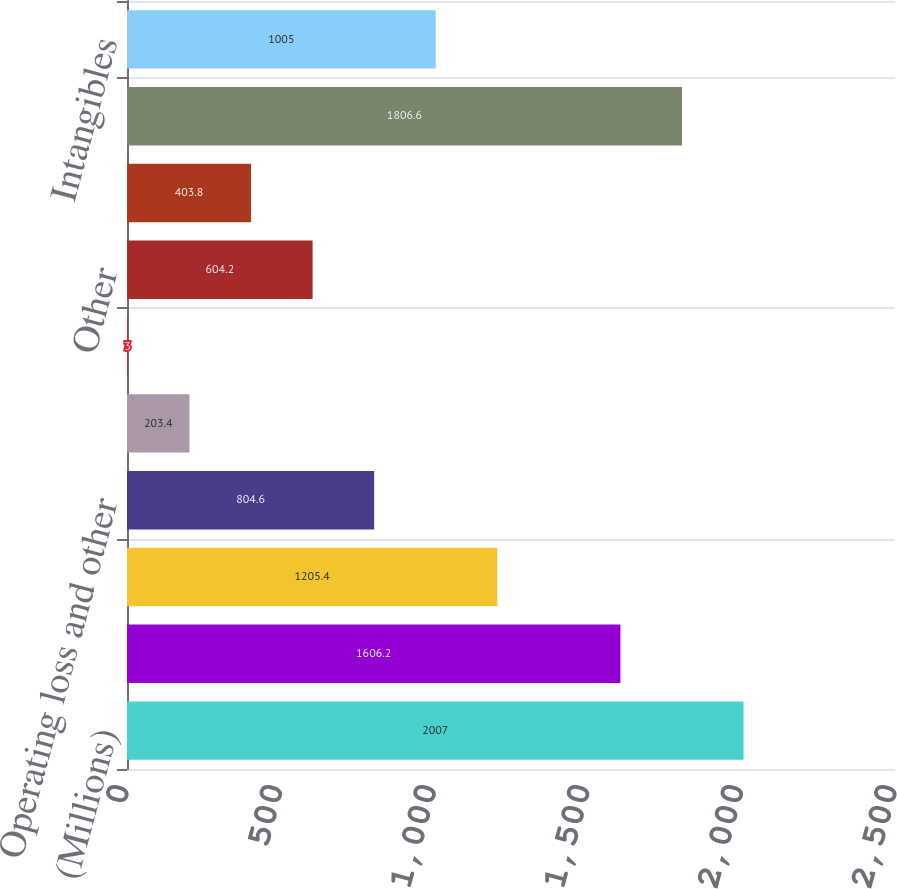Convert chart to OTSL. <chart><loc_0><loc_0><loc_500><loc_500><bar_chart><fcel>(Millions)<fcel>Employee benefits<fcel>Contingent and accrued<fcel>Operating loss and other<fcel>Inventories<fcel>Property<fcel>Other<fcel>Valuation allowance<fcel>Total<fcel>Intangibles<nl><fcel>2007<fcel>1606.2<fcel>1205.4<fcel>804.6<fcel>203.4<fcel>3<fcel>604.2<fcel>403.8<fcel>1806.6<fcel>1005<nl></chart> 